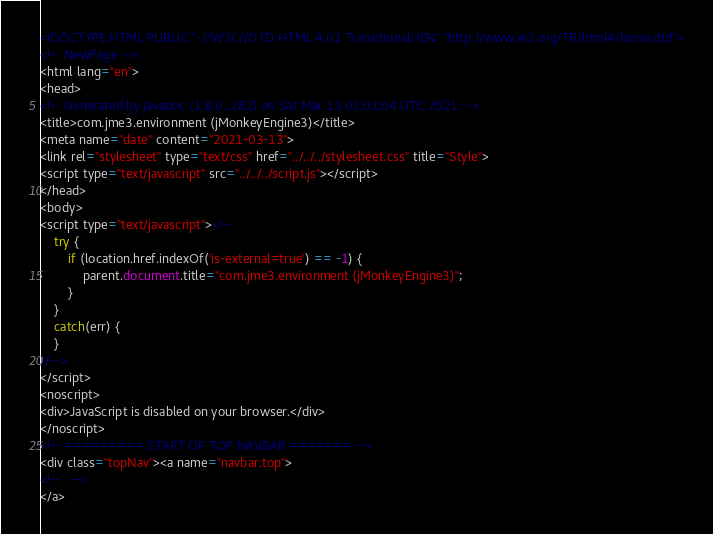Convert code to text. <code><loc_0><loc_0><loc_500><loc_500><_HTML_><!DOCTYPE HTML PUBLIC "-//W3C//DTD HTML 4.01 Transitional//EN" "http://www.w3.org/TR/html4/loose.dtd">
<!-- NewPage -->
<html lang="en">
<head>
<!-- Generated by javadoc (1.8.0_282) on Sat Mar 13 03:01:04 UTC 2021 -->
<title>com.jme3.environment (jMonkeyEngine3)</title>
<meta name="date" content="2021-03-13">
<link rel="stylesheet" type="text/css" href="../../../stylesheet.css" title="Style">
<script type="text/javascript" src="../../../script.js"></script>
</head>
<body>
<script type="text/javascript"><!--
    try {
        if (location.href.indexOf('is-external=true') == -1) {
            parent.document.title="com.jme3.environment (jMonkeyEngine3)";
        }
    }
    catch(err) {
    }
//-->
</script>
<noscript>
<div>JavaScript is disabled on your browser.</div>
</noscript>
<!-- ========= START OF TOP NAVBAR ======= -->
<div class="topNav"><a name="navbar.top">
<!--   -->
</a></code> 